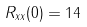Convert formula to latex. <formula><loc_0><loc_0><loc_500><loc_500>R _ { x x } ( 0 ) = 1 4</formula> 